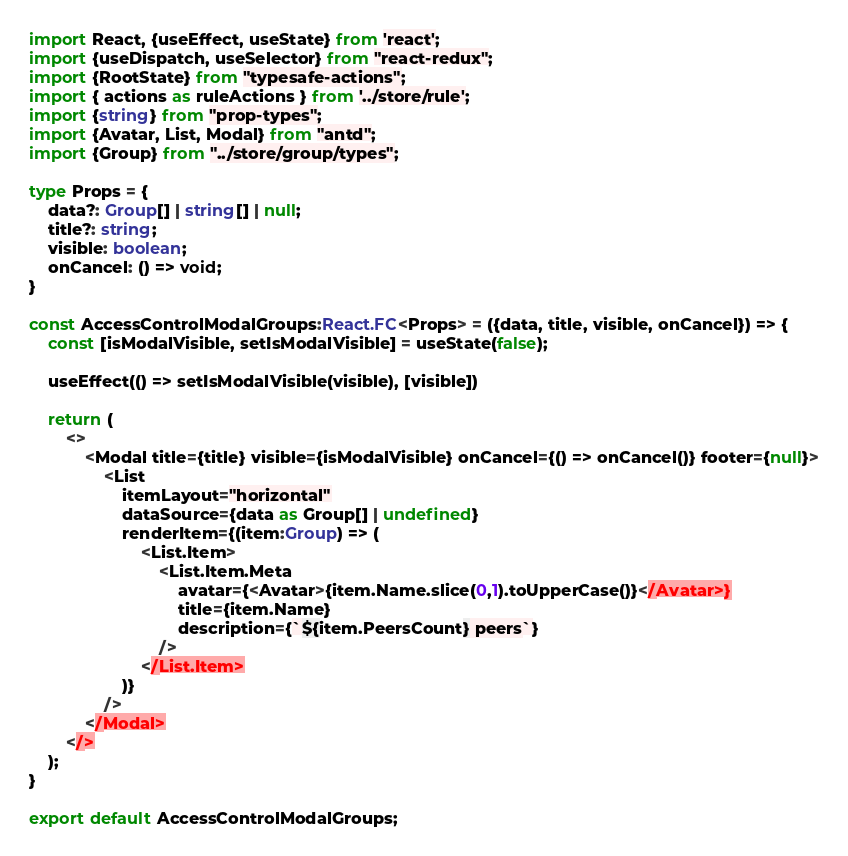Convert code to text. <code><loc_0><loc_0><loc_500><loc_500><_TypeScript_>import React, {useEffect, useState} from 'react';
import {useDispatch, useSelector} from "react-redux";
import {RootState} from "typesafe-actions";
import { actions as ruleActions } from '../store/rule';
import {string} from "prop-types";
import {Avatar, List, Modal} from "antd";
import {Group} from "../store/group/types";

type Props = {
    data?: Group[] | string[] | null;
    title?: string;
    visible: boolean;
    onCancel: () => void;
}

const AccessControlModalGroups:React.FC<Props> = ({data, title, visible, onCancel}) => {
    const [isModalVisible, setIsModalVisible] = useState(false);

    useEffect(() => setIsModalVisible(visible), [visible])

    return (
        <>
            <Modal title={title} visible={isModalVisible} onCancel={() => onCancel()} footer={null}>
                <List
                    itemLayout="horizontal"
                    dataSource={data as Group[] | undefined}
                    renderItem={(item:Group) => (
                        <List.Item>
                            <List.Item.Meta
                                avatar={<Avatar>{item.Name.slice(0,1).toUpperCase()}</Avatar>}
                                title={item.Name}
                                description={`${item.PeersCount} peers`}
                            />
                        </List.Item>
                    )}
                />
            </Modal>
        </>
    );
}

export default AccessControlModalGroups;</code> 